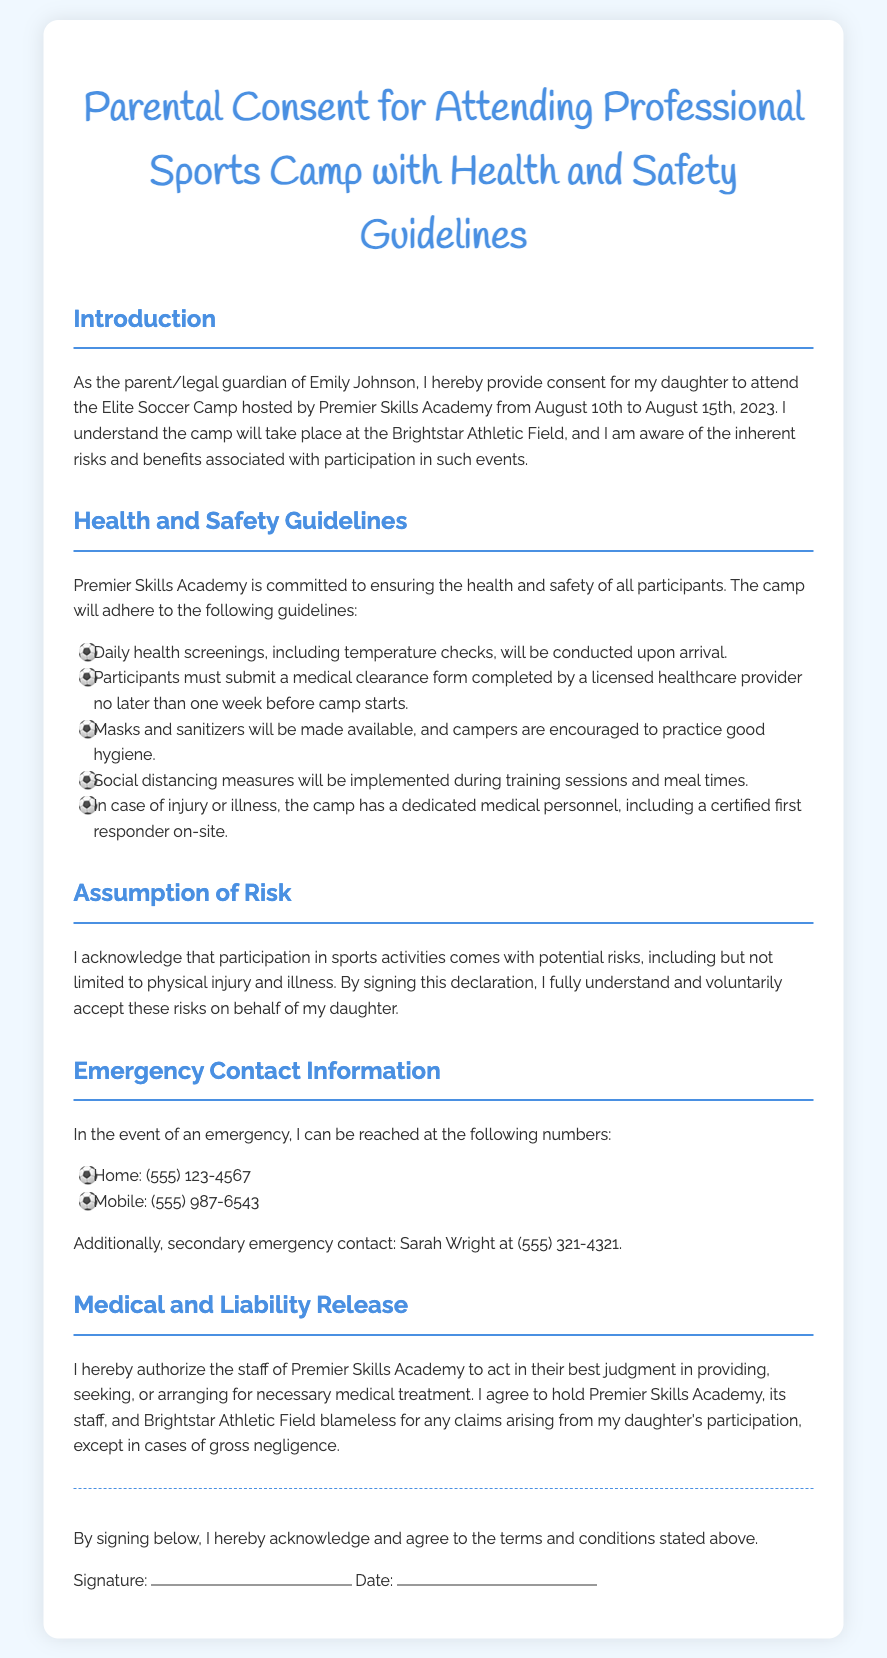What is the name of the camp? The camp is referred to as the Elite Soccer Camp in the document.
Answer: Elite Soccer Camp What are the dates of the camp? The camp is scheduled to take place from August 10th to August 15th, 2023.
Answer: August 10th to August 15th, 2023 Who is the primary emergency contact? The primary emergency contact information is provided in the section about Emergency Contact Information.
Answer: (555) 123-4567 What health screen will be conducted daily? The document states that daily health screenings, including temperature checks, will be conducted.
Answer: Temperature checks What must participants submit before attending camp? Participants must submit a medical clearance form completed by a licensed healthcare provider.
Answer: Medical clearance form What is the purpose of the liability release? The liability release gives the staff permission to provide, seek, or arrange for necessary medical treatment for the participants.
Answer: Necessary medical treatment What type of facility is the camp located at? The document mentions that the camp will take place at Brightstar Athletic Field.
Answer: Brightstar Athletic Field How can the camp staff be held accountable? The document states that claims can arise from the daughter's participation, except in cases of gross negligence.
Answer: Gross negligence 